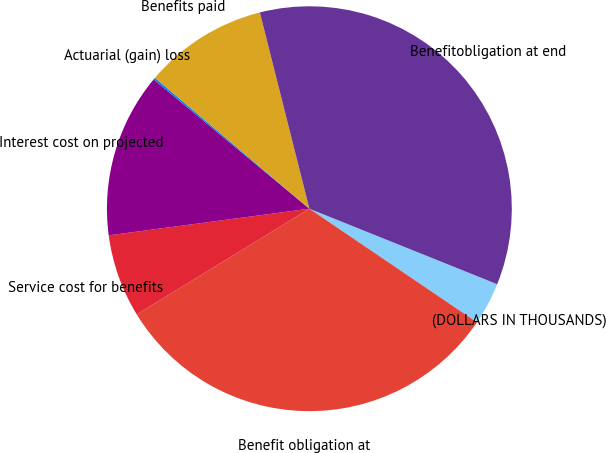<chart> <loc_0><loc_0><loc_500><loc_500><pie_chart><fcel>(DOLLARS IN THOUSANDS)<fcel>Benefit obligation at<fcel>Service cost for benefits<fcel>Interest cost on projected<fcel>Actuarial (gain) loss<fcel>Benefits paid<fcel>Benefitobligation at end<nl><fcel>3.4%<fcel>31.78%<fcel>6.64%<fcel>13.13%<fcel>0.16%<fcel>9.88%<fcel>35.02%<nl></chart> 